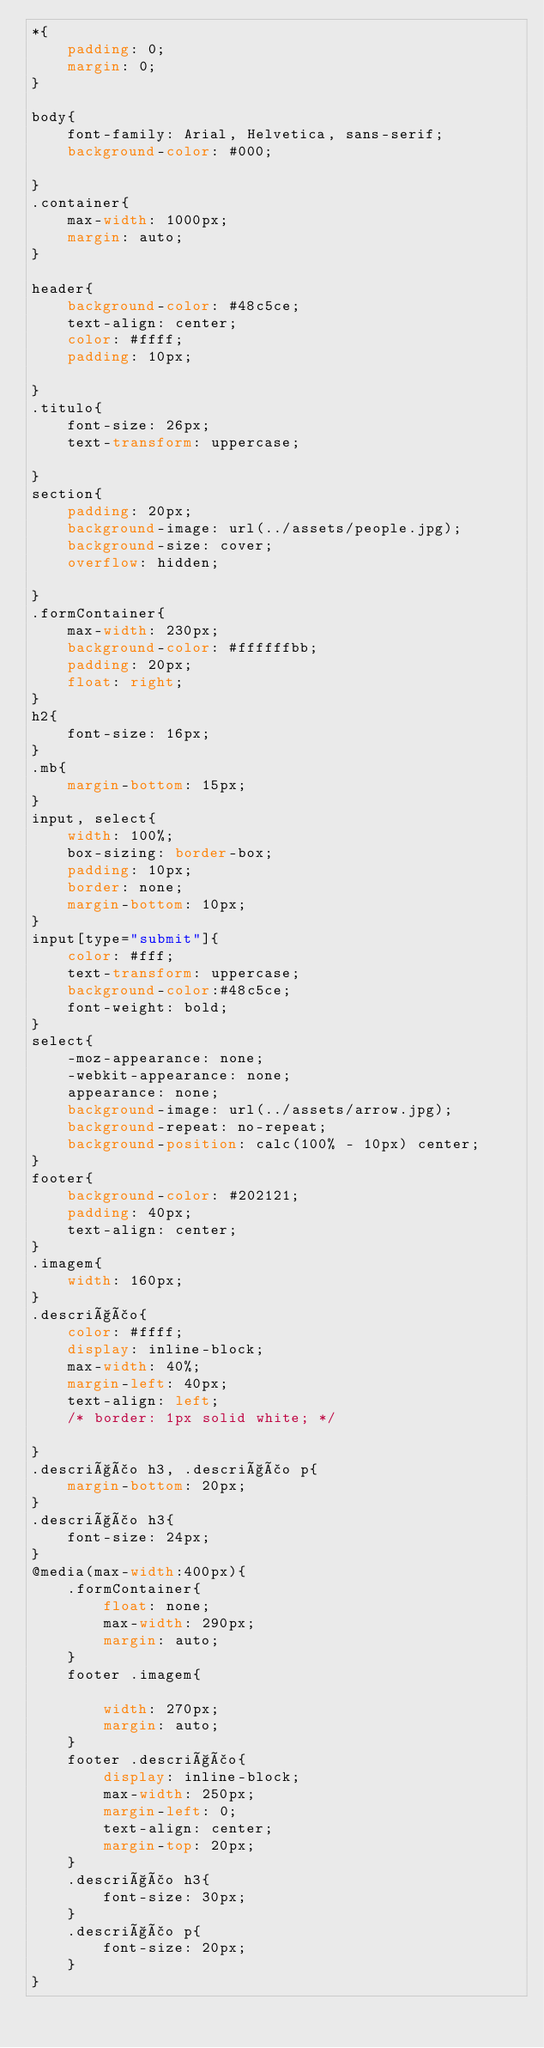Convert code to text. <code><loc_0><loc_0><loc_500><loc_500><_CSS_>*{
    padding: 0;
    margin: 0;
}

body{
    font-family: Arial, Helvetica, sans-serif;
    background-color: #000;
   
}
.container{
    max-width: 1000px;
    margin: auto;
}

header{
    background-color: #48c5ce;
    text-align: center;
    color: #ffff;
    padding: 10px;
    
}
.titulo{
    font-size: 26px;
    text-transform: uppercase;

}
section{
    padding: 20px;
    background-image: url(../assets/people.jpg);
    background-size: cover;
    overflow: hidden;
    
}
.formContainer{
    max-width: 230px;
    background-color: #ffffffbb;
    padding: 20px;
    float: right;
}
h2{
    font-size: 16px;
}
.mb{
    margin-bottom: 15px;
}
input, select{
    width: 100%;
    box-sizing: border-box;
    padding: 10px;
    border: none;
    margin-bottom: 10px;
}
input[type="submit"]{
    color: #fff;
    text-transform: uppercase;
    background-color:#48c5ce;
    font-weight: bold;
}
select{
    -moz-appearance: none;
    -webkit-appearance: none;
    appearance: none;
    background-image: url(../assets/arrow.jpg);
    background-repeat: no-repeat;
    background-position: calc(100% - 10px) center;   
}
footer{
    background-color: #202121;
    padding: 40px;
    text-align: center;
}
.imagem{
    width: 160px;
}
.descrição{
    color: #ffff;
    display: inline-block;
    max-width: 40%;
    margin-left: 40px;
    text-align: left;
    /* border: 1px solid white; */

}
.descrição h3, .descrição p{
    margin-bottom: 20px;
}
.descrição h3{
    font-size: 24px;
}
@media(max-width:400px){
    .formContainer{
        float: none;
        max-width: 290px;    
        margin: auto;   
    }
    footer .imagem{
        
        width: 270px;
        margin: auto;
    }
    footer .descrição{
        display: inline-block;
        max-width: 250px;
        margin-left: 0;
        text-align: center;
        margin-top: 20px;
    }
    .descrição h3{
        font-size: 30px;
    }
    .descrição p{
        font-size: 20px;
    }
}

</code> 